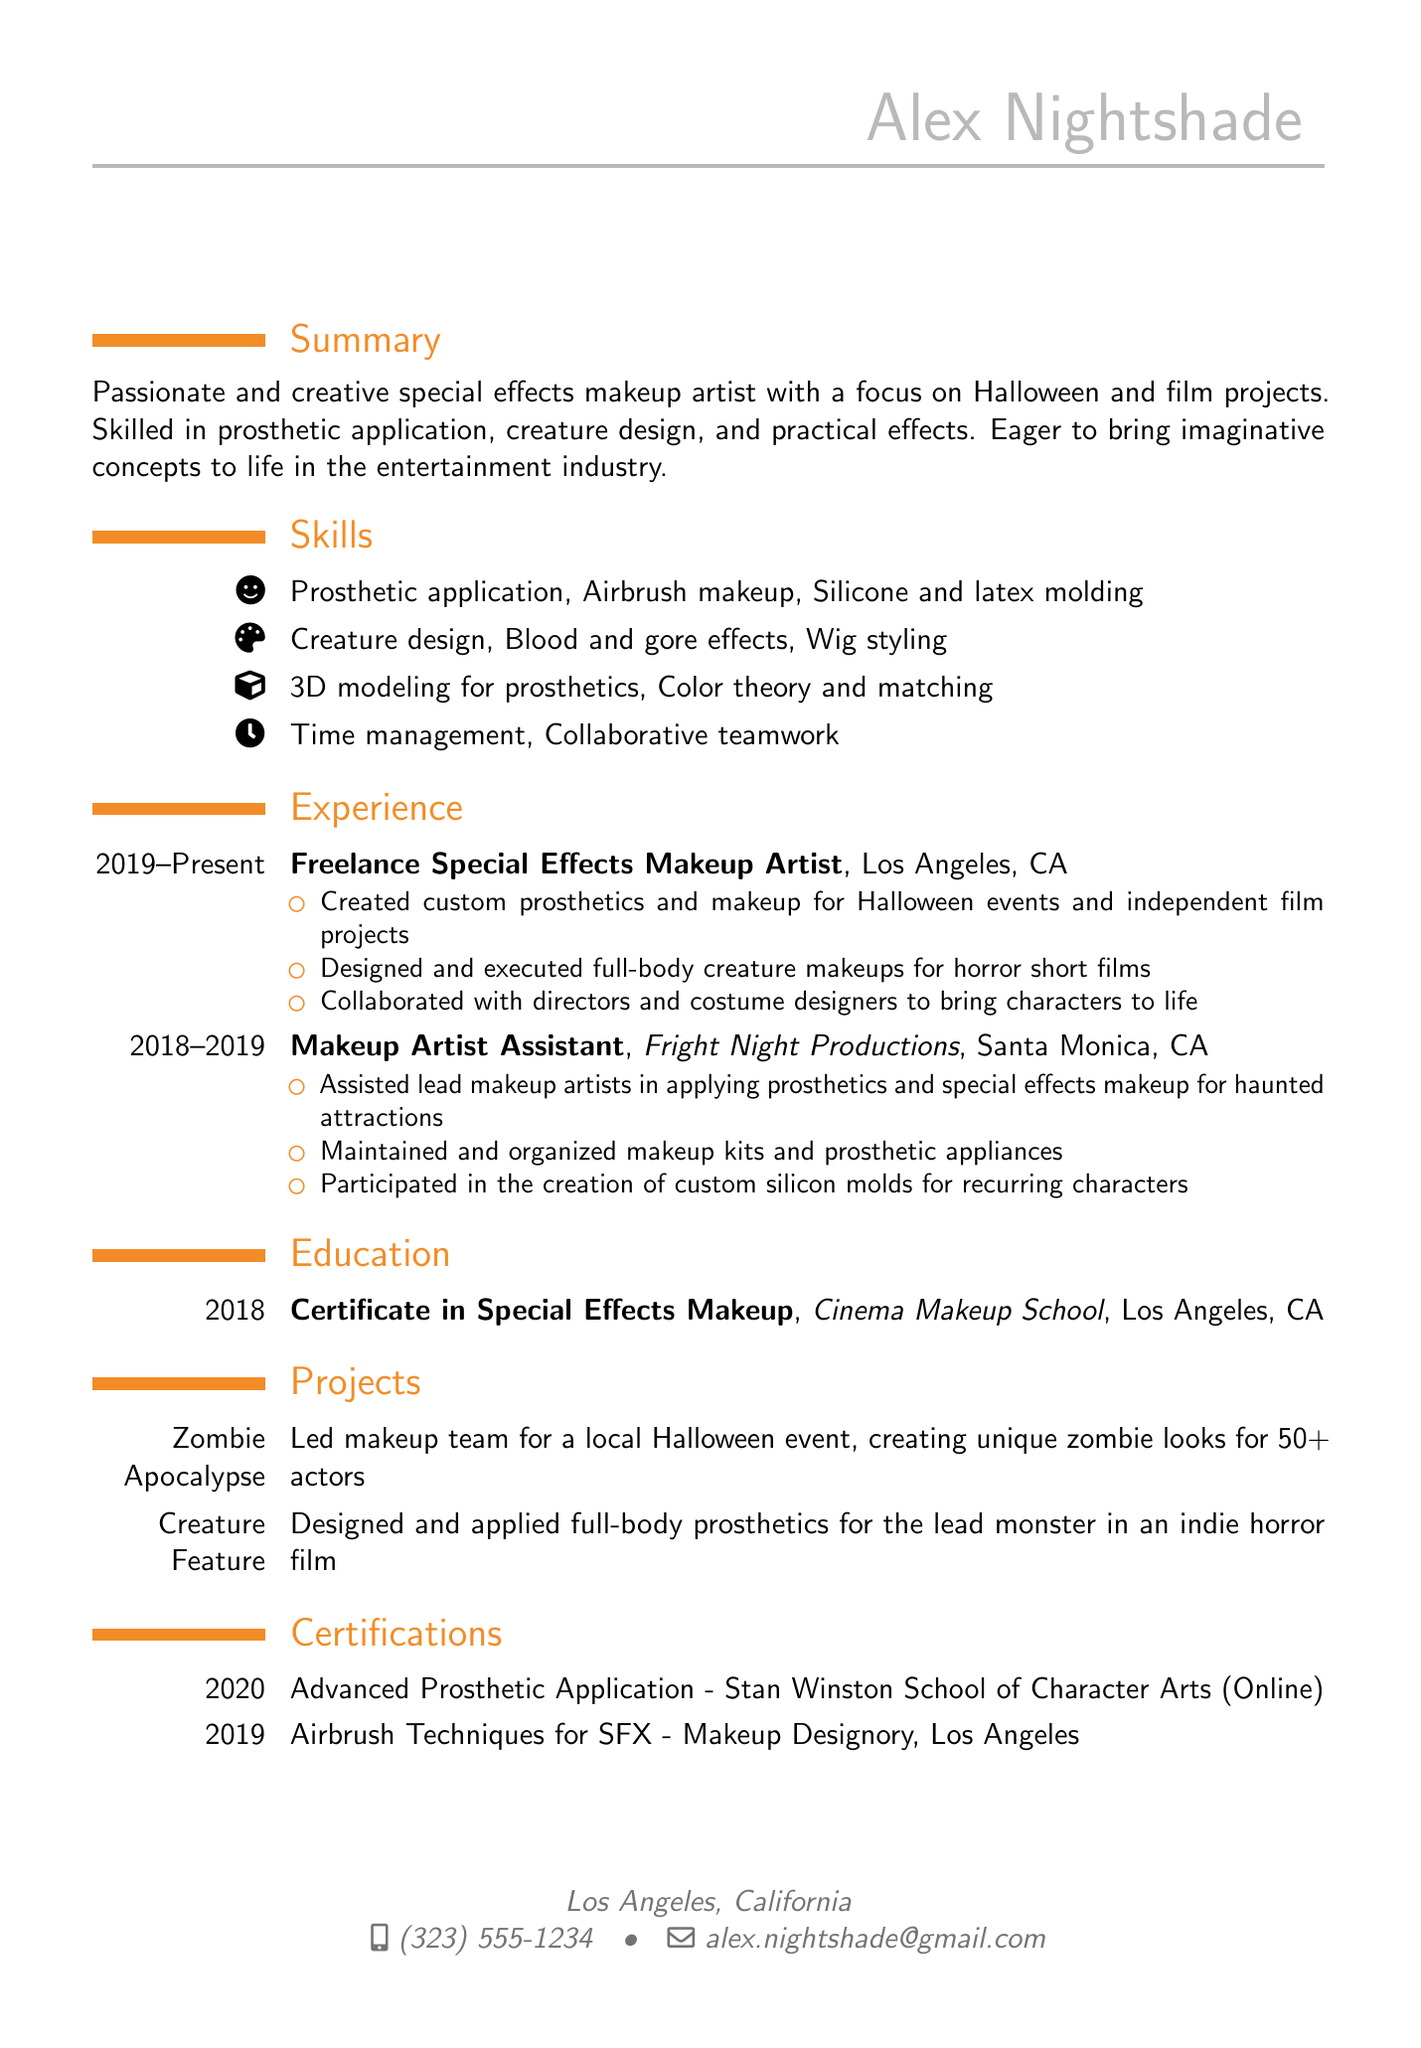What is the name of the artist? The name of the artist is provided in the personal info section of the document.
Answer: Alex Nightshade What city is the artist located in? The location is mentioned in the personal info section.
Answer: Los Angeles, California What is the certification obtained in 2018? The education section lists the degree obtained and the year of graduation.
Answer: Certificate in Special Effects Makeup How long did the artist work as a Makeup Artist Assistant? The experience section specifies the duration of this role.
Answer: 1 year What is one skill related to creature design? The skills section highlights skills that relate to creature design specifically.
Answer: Creature design What project involved creating unique zombie looks? The projects section gives names and descriptions of the artist's work.
Answer: Zombie Apocalypse How many actors were involved in the Zombie Apocalypse project? The description of the project provides specific numbers relevant to the involvement.
Answer: 50+ What online school did the artist attend for Advanced Prosthetic Application? The certifications section names the institution where the certification was obtained online.
Answer: Stan Winston School of Character Arts Which type of makeup involves airbrush techniques? The skills section includes specific techniques that correlate with special effects makeup types.
Answer: SFX 